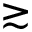<formula> <loc_0><loc_0><loc_500><loc_500>{ \gtrsim }</formula> 